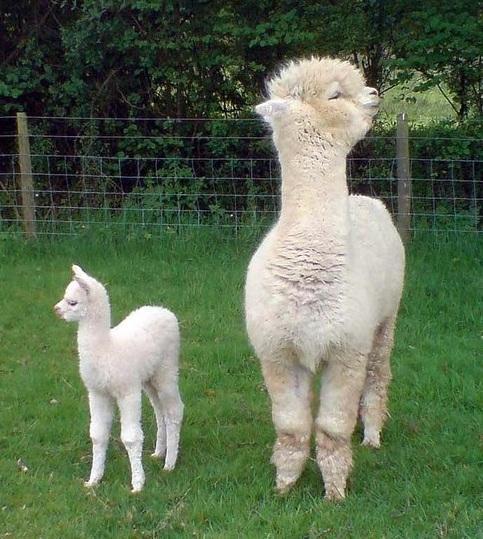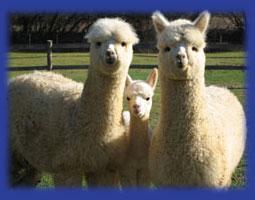The first image is the image on the left, the second image is the image on the right. Assess this claim about the two images: "There is a young llama in both images.". Correct or not? Answer yes or no. Yes. The first image is the image on the left, the second image is the image on the right. For the images shown, is this caption "Every llama appears to be looking directly at the viewer (i.e. facing the camera)." true? Answer yes or no. No. 